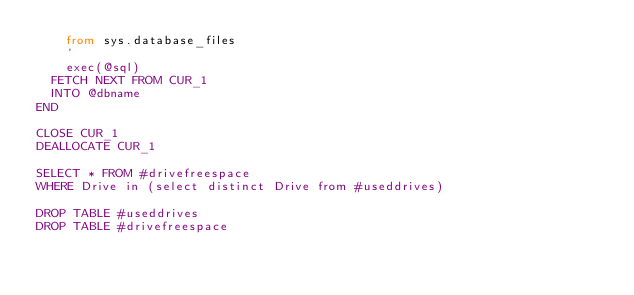<code> <loc_0><loc_0><loc_500><loc_500><_SQL_>		from sys.database_files
		'
		exec(@sql)
	FETCH NEXT FROM CUR_1
	INTO @dbname
END

CLOSE CUR_1
DEALLOCATE CUR_1

SELECT * FROM #drivefreespace
WHERE Drive in (select distinct Drive from #useddrives)

DROP TABLE #useddrives
DROP TABLE #drivefreespace
</code> 